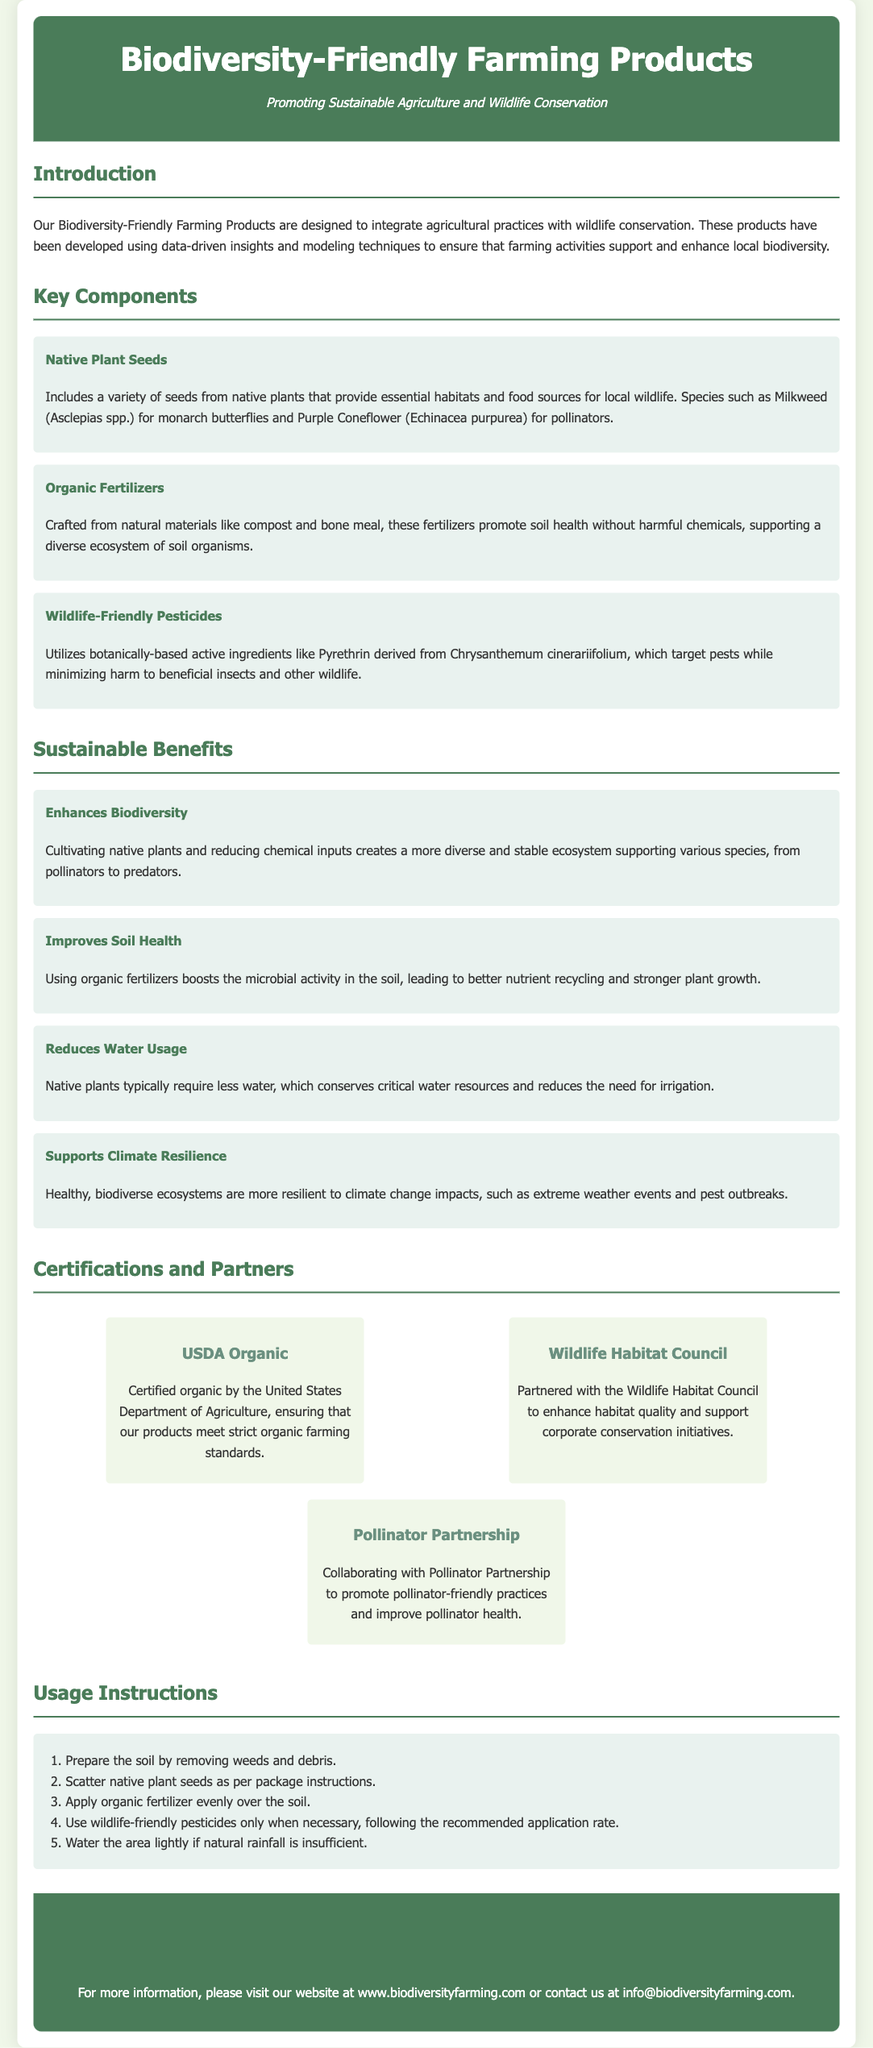What is the purpose of Biodiversity-Friendly Farming Products? The purpose is to integrate agricultural practices with wildlife conservation.
Answer: Integrate agricultural practices with wildlife conservation What types of seeds are included in the key components? The key components include a variety of native plant seeds that provide habitats and food sources for wildlife.
Answer: Native plant seeds What is an example of a native plant mentioned? An example of a native plant mentioned is Milkweed for monarch butterflies.
Answer: Milkweed What certification is obtained from the United States Department of Agriculture? The certification obtained is USDA Organic.
Answer: USDA Organic Which benefit of using native plants relates to water conservation? The benefit that relates to water conservation is that native plants typically require less water.
Answer: Requires less water What type of ingredients do wildlife-friendly pesticides utilize? Wildlife-friendly pesticides utilize botanically-based active ingredients.
Answer: Botanically-based active ingredients How many steps are included in the usage instructions? There are five steps included in the usage instructions.
Answer: Five steps What is a partner of the Biodiversity-Friendly Farming Products? A partner is the Wildlife Habitat Council.
Answer: Wildlife Habitat Council What does applying organic fertilizers boost in the soil? Applying organic fertilizers boosts microbial activity in the soil.
Answer: Microbial activity 